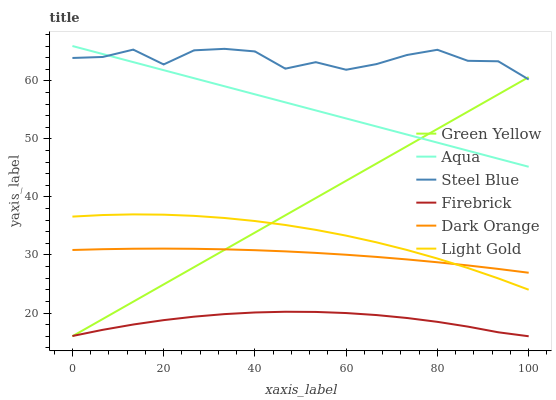Does Firebrick have the minimum area under the curve?
Answer yes or no. Yes. Does Steel Blue have the maximum area under the curve?
Answer yes or no. Yes. Does Aqua have the minimum area under the curve?
Answer yes or no. No. Does Aqua have the maximum area under the curve?
Answer yes or no. No. Is Green Yellow the smoothest?
Answer yes or no. Yes. Is Steel Blue the roughest?
Answer yes or no. Yes. Is Firebrick the smoothest?
Answer yes or no. No. Is Firebrick the roughest?
Answer yes or no. No. Does Firebrick have the lowest value?
Answer yes or no. Yes. Does Aqua have the lowest value?
Answer yes or no. No. Does Aqua have the highest value?
Answer yes or no. Yes. Does Firebrick have the highest value?
Answer yes or no. No. Is Light Gold less than Steel Blue?
Answer yes or no. Yes. Is Aqua greater than Dark Orange?
Answer yes or no. Yes. Does Light Gold intersect Dark Orange?
Answer yes or no. Yes. Is Light Gold less than Dark Orange?
Answer yes or no. No. Is Light Gold greater than Dark Orange?
Answer yes or no. No. Does Light Gold intersect Steel Blue?
Answer yes or no. No. 